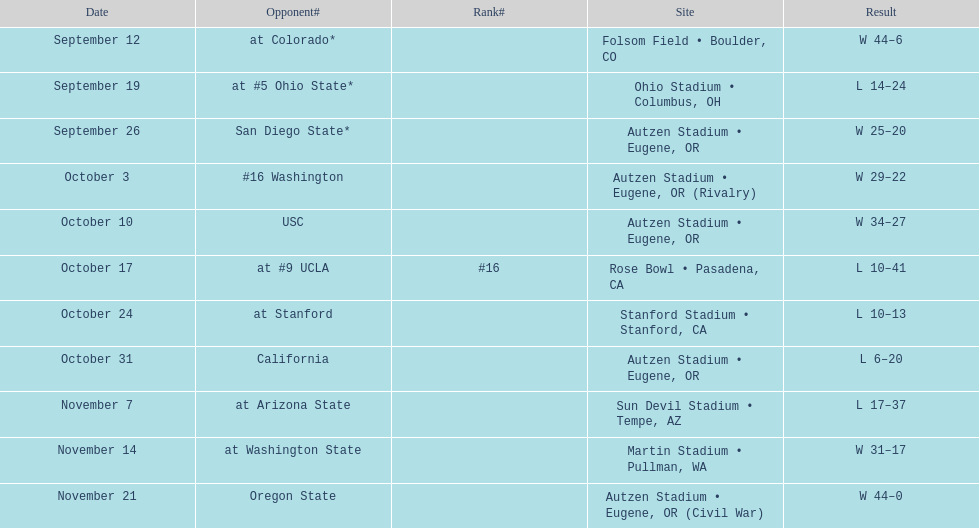Were the results of the game of november 14 above or below the results of the october 17 game? Above. 